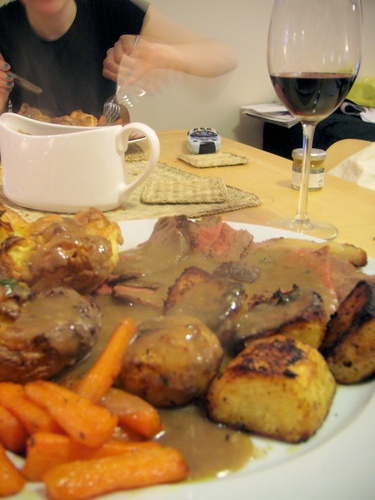Describe the objects in this image and their specific colors. I can see people in olive, black, tan, and brown tones, carrot in olive, red, orange, and brown tones, cup in olive, tan, and beige tones, dining table in olive, khaki, and tan tones, and wine glass in olive, tan, and black tones in this image. 